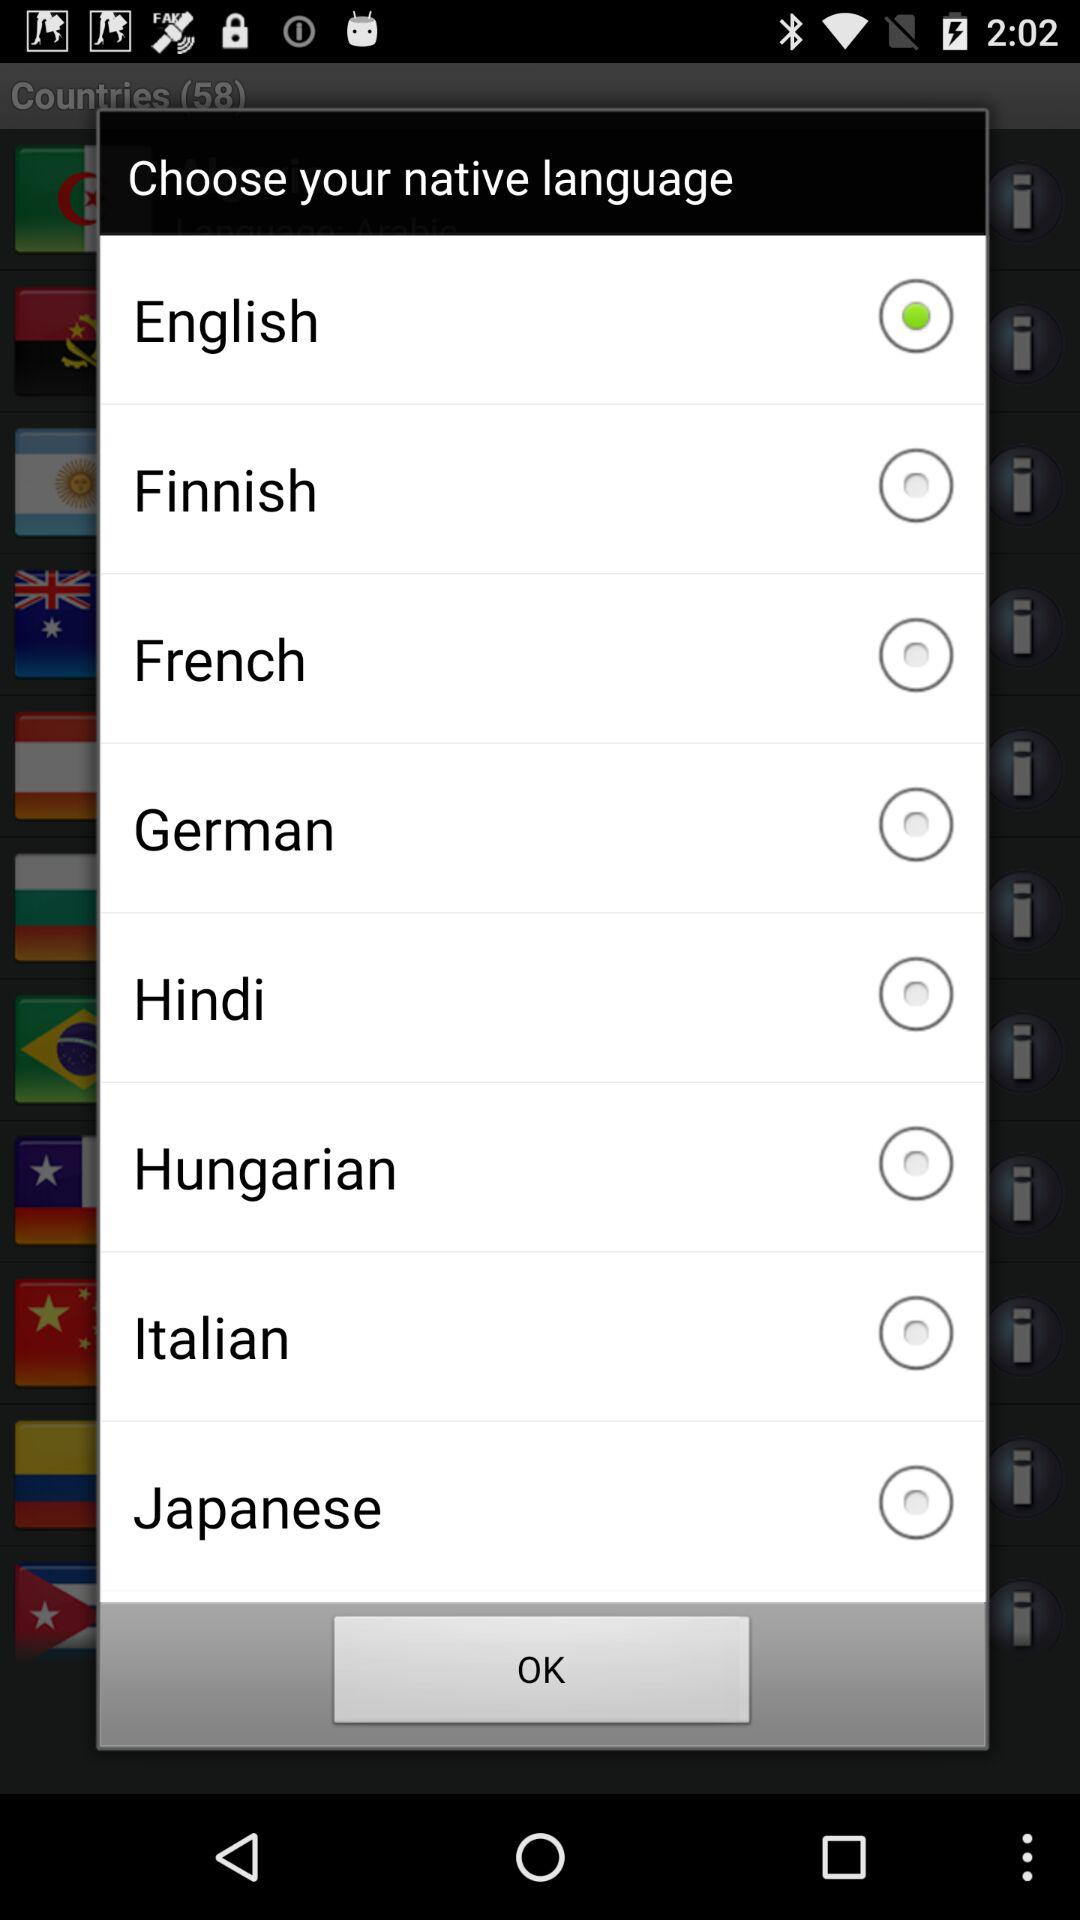How many languages are available to choose from?
Answer the question using a single word or phrase. 8 